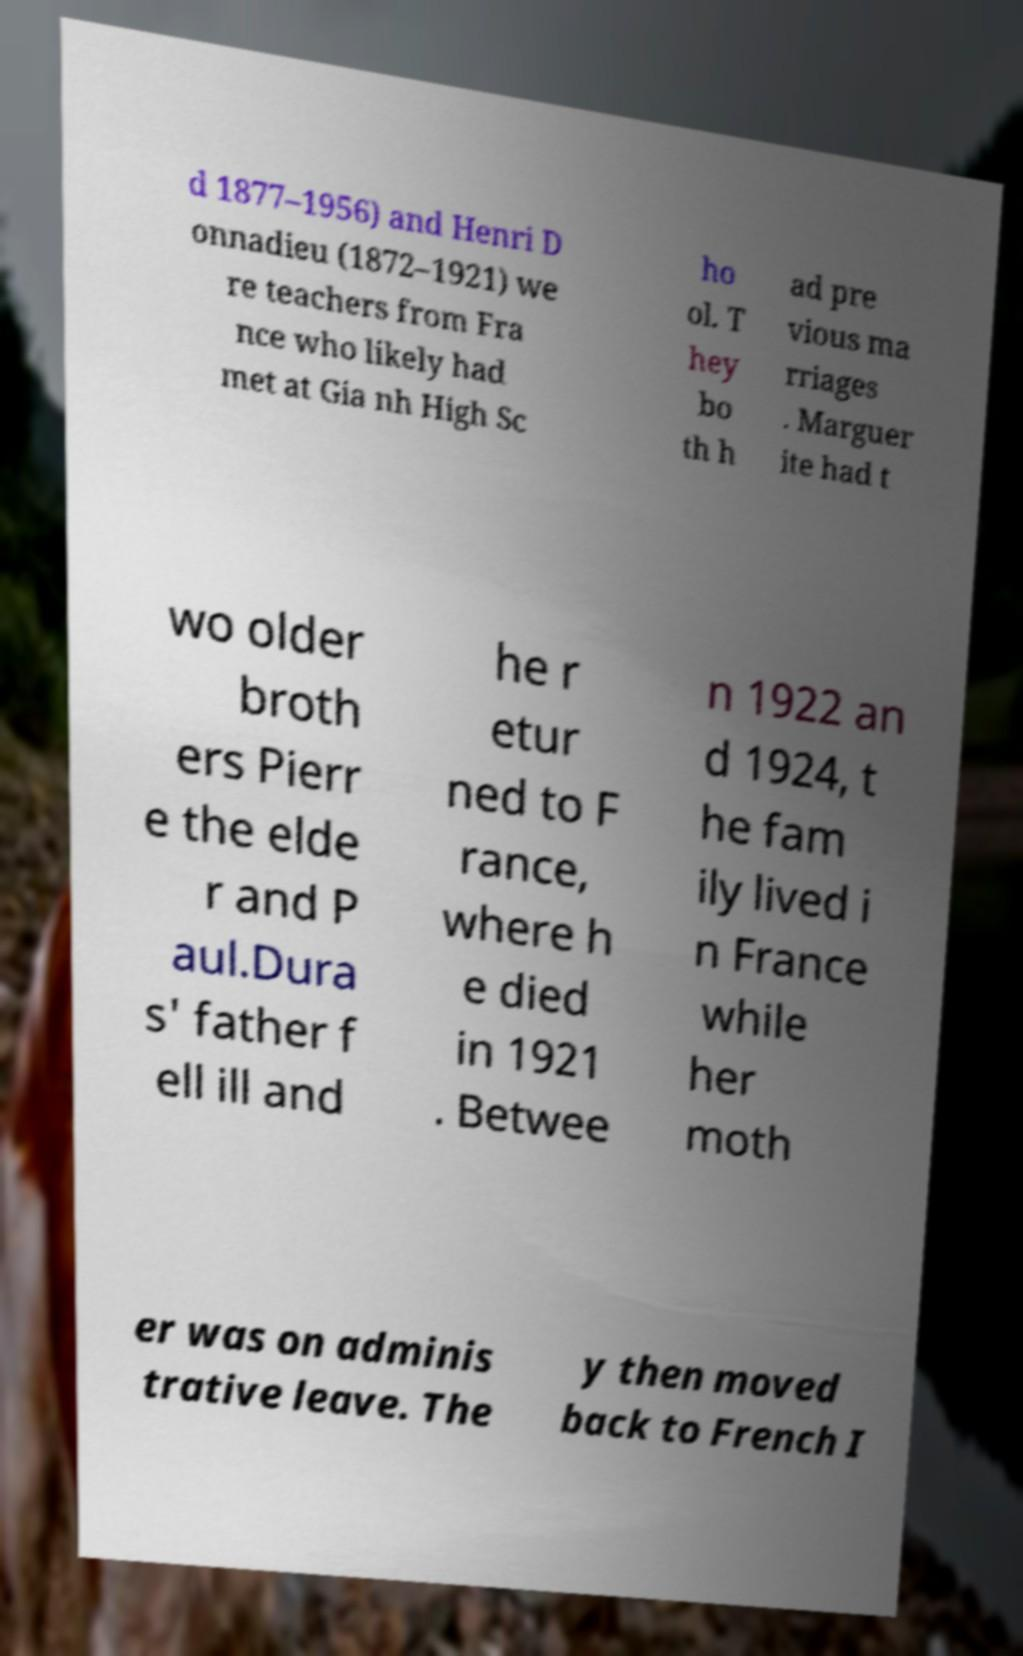What messages or text are displayed in this image? I need them in a readable, typed format. d 1877–1956) and Henri D onnadieu (1872–1921) we re teachers from Fra nce who likely had met at Gia nh High Sc ho ol. T hey bo th h ad pre vious ma rriages . Marguer ite had t wo older broth ers Pierr e the elde r and P aul.Dura s' father f ell ill and he r etur ned to F rance, where h e died in 1921 . Betwee n 1922 an d 1924, t he fam ily lived i n France while her moth er was on adminis trative leave. The y then moved back to French I 